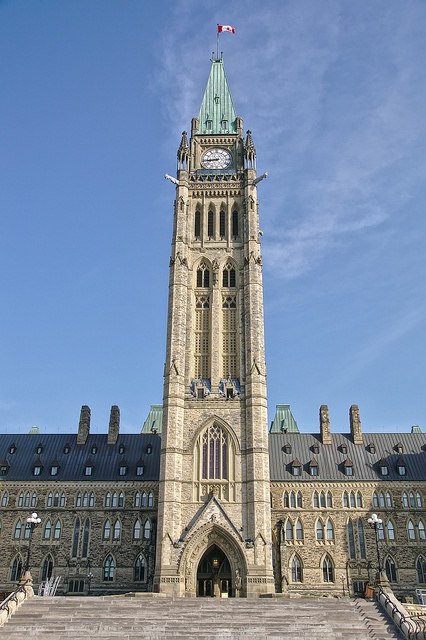Describe the objects in this image and their specific colors. I can see a clock in gray, darkgray, lightgray, and black tones in this image. 